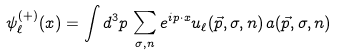Convert formula to latex. <formula><loc_0><loc_0><loc_500><loc_500>\psi ^ { ( + ) } _ { \ell } ( x ) = \int d ^ { 3 } p \, \sum _ { \sigma , n } e ^ { i p \cdot x } u _ { \ell } ( { \vec { p } } , \sigma , n ) \, a ( { \vec { p } } , \sigma , n )</formula> 